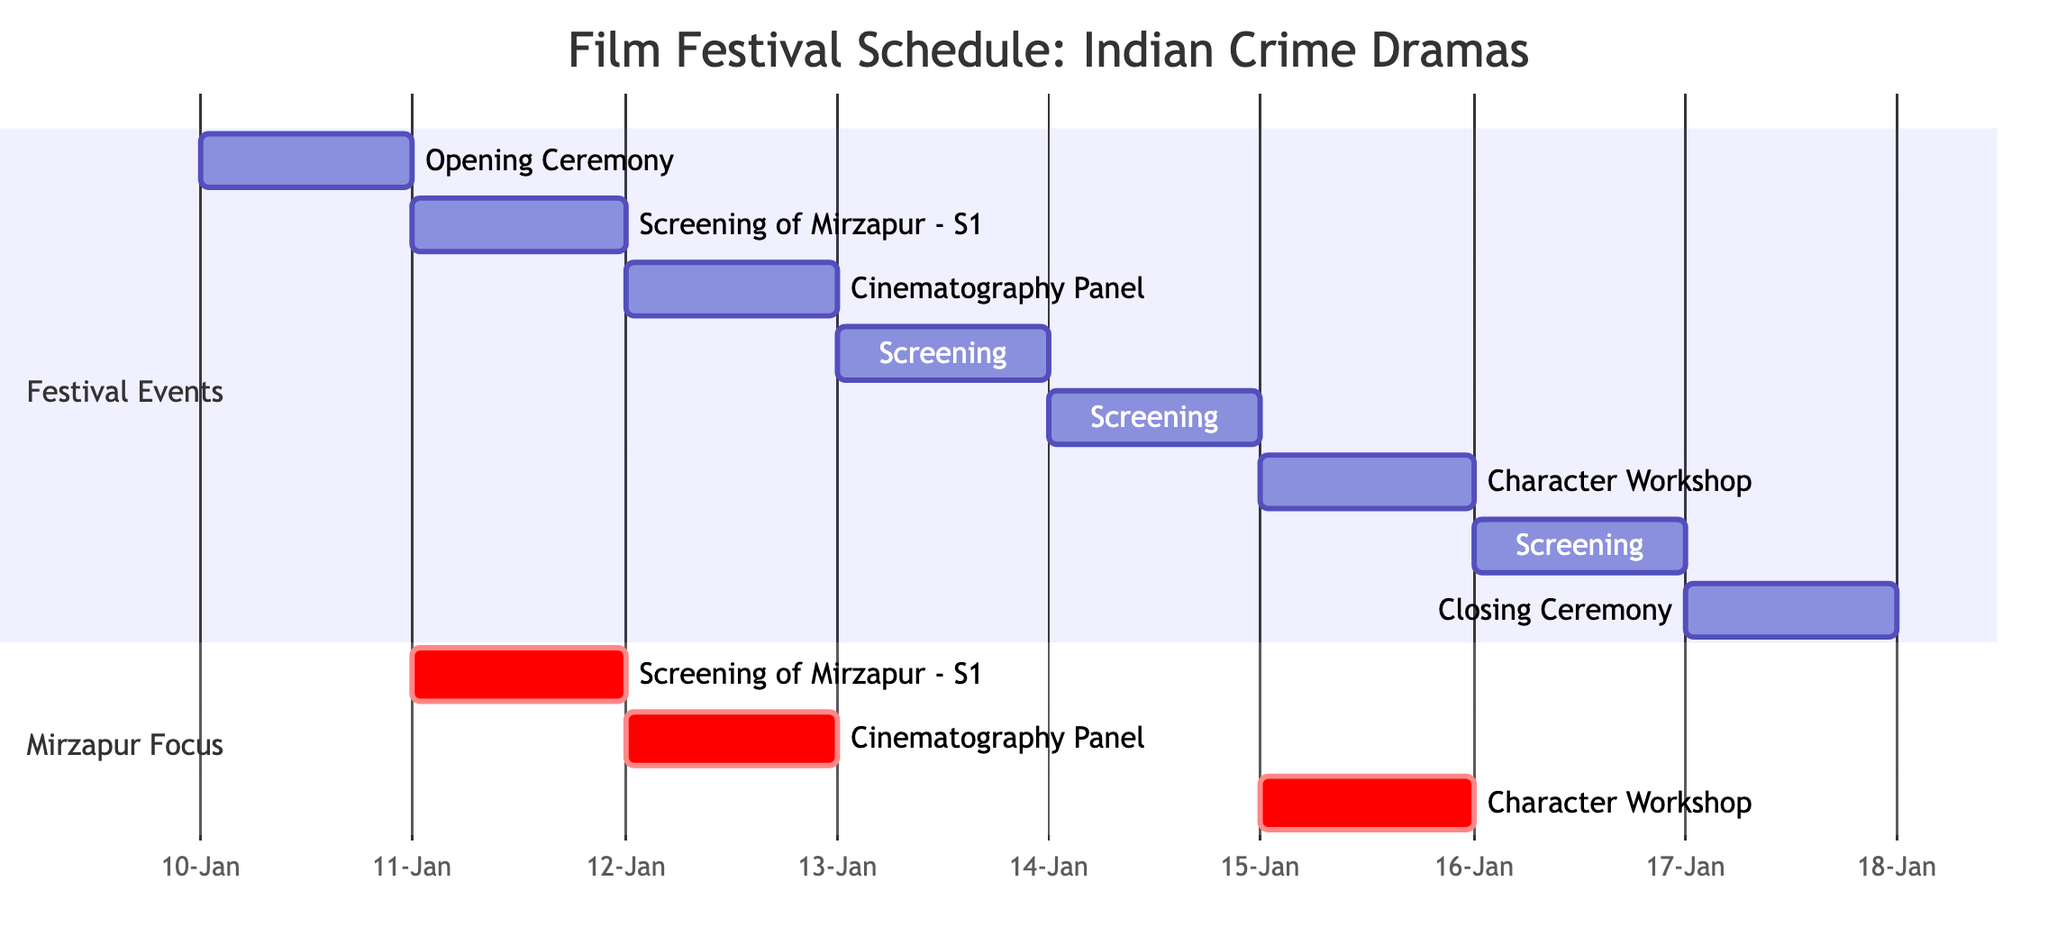What is the duration of the festival? The festival spans from the opening ceremony on January 10, 2024, to the closing ceremony on January 17, 2024. This gives a total duration of 7 days.
Answer: 7 days Which film is screened immediately after the opening ceremony? Following the opening ceremony on January 10, 2024, the next event is the screening of Mirzapur - Season 1, which occurs on January 11, 2024.
Answer: Screening of Mirzapur - Season 1 How many workshops are included in the schedule? In the schedule, there are two workshops mentioned: the Cinematography Panel and the Character Development Workshop, which are held on January 12 and January 15, 2024, respectively.
Answer: 2 On what date is the Character Development Workshop scheduled? The Character Development Workshop is scheduled for January 15, 2024, based on the timeline represented in the Gantt chart.
Answer: January 15, 2024 What event occurs on January 13, 2024? On January 13, 2024, the screening of Gangs of Wasseypur is scheduled, as indicated in the timeline.
Answer: Screening of Gangs of Wasseypur Which event is focused on Mirzapur? The events specifically focused on Mirzapur include the Screening of Mirzapur - Season 1, the Cinematography Panel, and the Character Development Workshop, as highlighted in the Mirzapur focus section.
Answer: Screening of Mirzapur - Season 1 What are the two events scheduled on January 14, 2024? On January 14, 2024, the schedule lists the screening of Sacred Games - Season 1, and the event itself is the only one on that day, so there is only one event.
Answer: Screening of Sacred Games - Season 1 How many screening events are scheduled throughout the festival? There are four screening events listed in the schedule: Mirzapur - Season 1, Gangs of Wasseypur, Sacred Games - Season 1, and Paatal Lok, totaling four separate events.
Answer: 4 